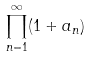<formula> <loc_0><loc_0><loc_500><loc_500>\prod _ { n = 1 } ^ { \infty } ( 1 + a _ { n } )</formula> 